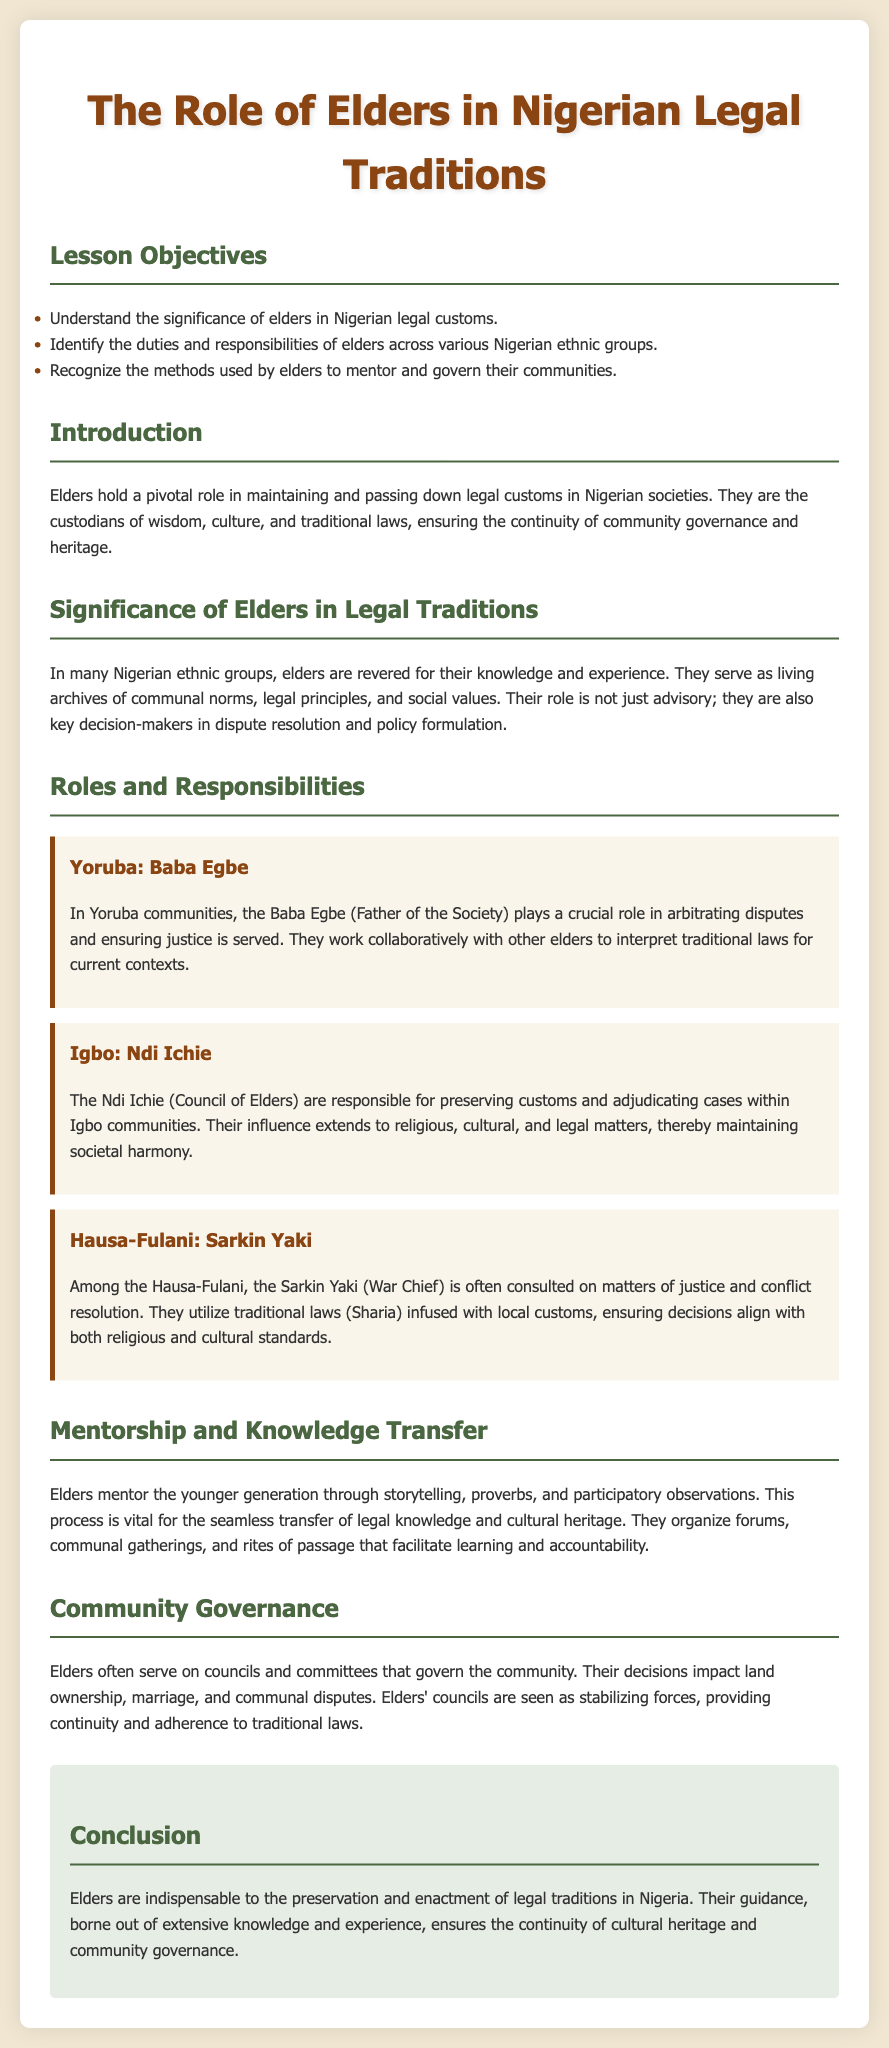what are the lesson objectives? The lesson objectives are listed in the document and focus on understanding the significance of elders, identifying their duties, and recognizing their methods in mentoring and governance.
Answer: significance of elders in Nigerian legal customs, duties and responsibilities of elders, methods used by elders to mentor and govern their communities who are the Yoruba community's key figures? The document specifies that in the Yoruba community, the key figure is the Baba Egbe.
Answer: Baba Egbe what role do Ndi Ichie serve in Igbo communities? The Ndi Ichie serve as the council responsible for preserving customs and adjudicating cases within Igbo communities.
Answer: preserving customs and adjudicating cases which ethnic group has Sarkin Yaki as a leader? The document indicates that the Sarkin Yaki is a key figure among the Hausa-Fulani community.
Answer: Hausa-Fulani how do elders transfer knowledge to the younger generation? The document explains that elders transfer knowledge through storytelling, proverbs, and participatory observations.
Answer: storytelling, proverbs, and participatory observations what is the conclusion about the role of elders? The conclusion states that elders are indispensable to the preservation and enactment of legal traditions in Nigeria.
Answer: indispensable to the preservation and enactment of legal traditions what is a major duty of elders in community governance? A major duty of elders in community governance includes making decisions that impact land ownership, marriage, and communal disputes.
Answer: decisions that impact land ownership, marriage, and communal disputes which traditional law is consulted by the Sarkin Yaki? The traditional law consulted by the Sarkin Yaki is Sharia, infused with local customs.
Answer: Sharia what is a primary method elders use for community mentorship? A primary method used by elders for community mentorship is organizing forums and communal gatherings.
Answer: organizing forums and communal gatherings 